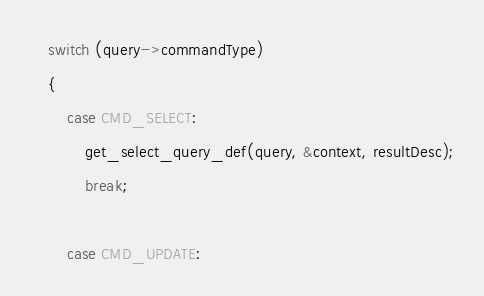<code> <loc_0><loc_0><loc_500><loc_500><_C_>	switch (query->commandType)
	{
		case CMD_SELECT:
			get_select_query_def(query, &context, resultDesc);
			break;

		case CMD_UPDATE:</code> 